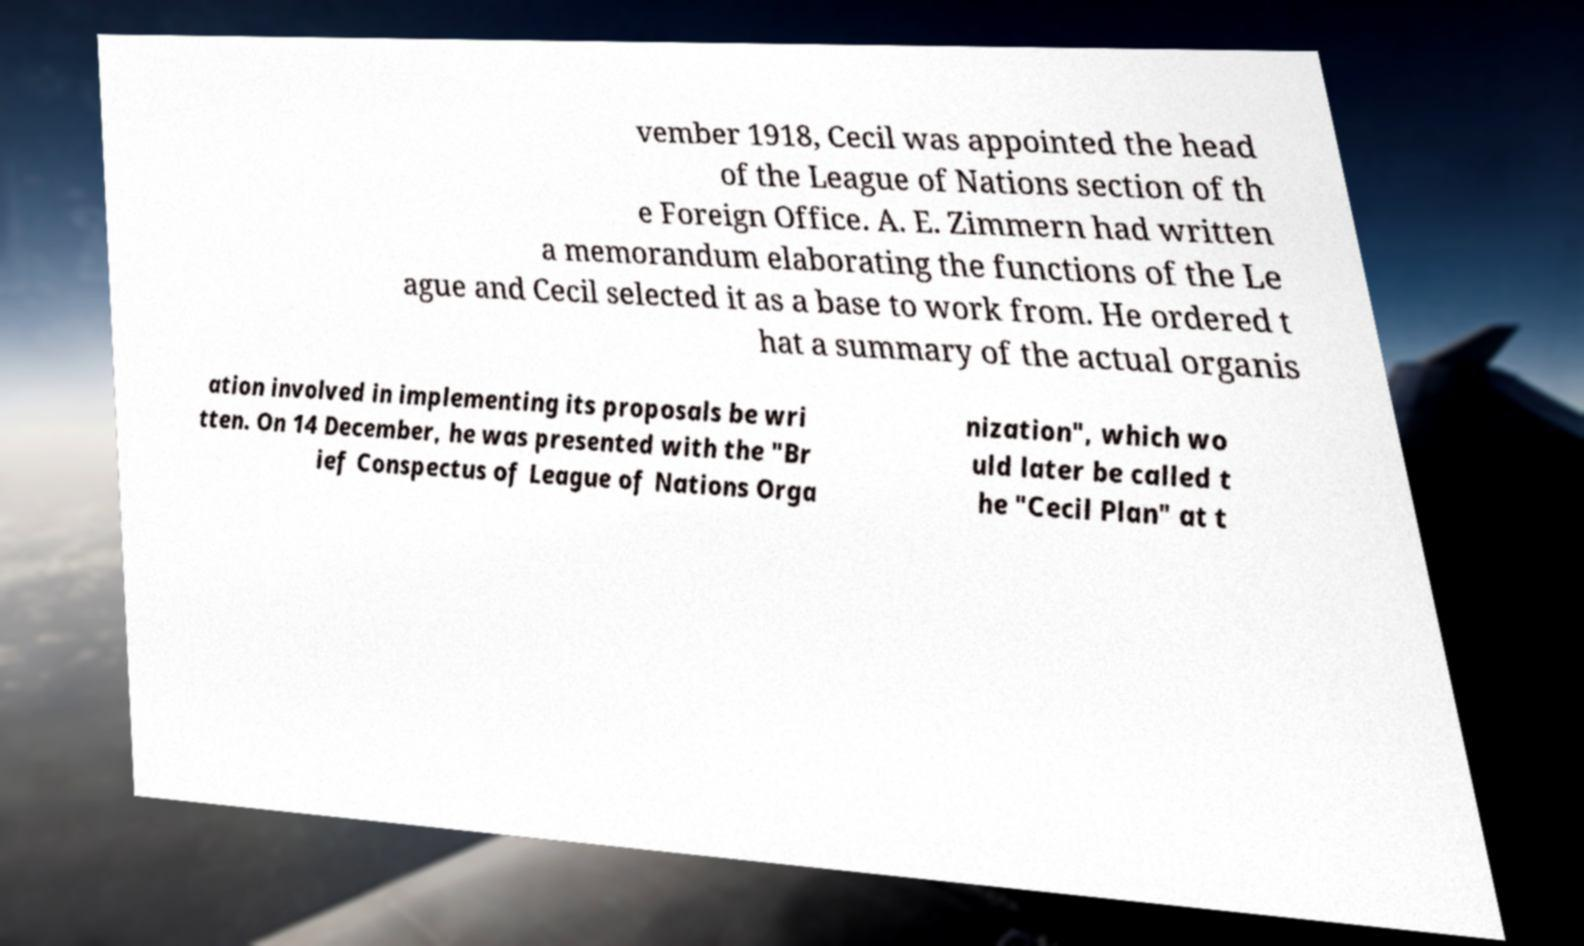For documentation purposes, I need the text within this image transcribed. Could you provide that? vember 1918, Cecil was appointed the head of the League of Nations section of th e Foreign Office. A. E. Zimmern had written a memorandum elaborating the functions of the Le ague and Cecil selected it as a base to work from. He ordered t hat a summary of the actual organis ation involved in implementing its proposals be wri tten. On 14 December, he was presented with the "Br ief Conspectus of League of Nations Orga nization", which wo uld later be called t he "Cecil Plan" at t 